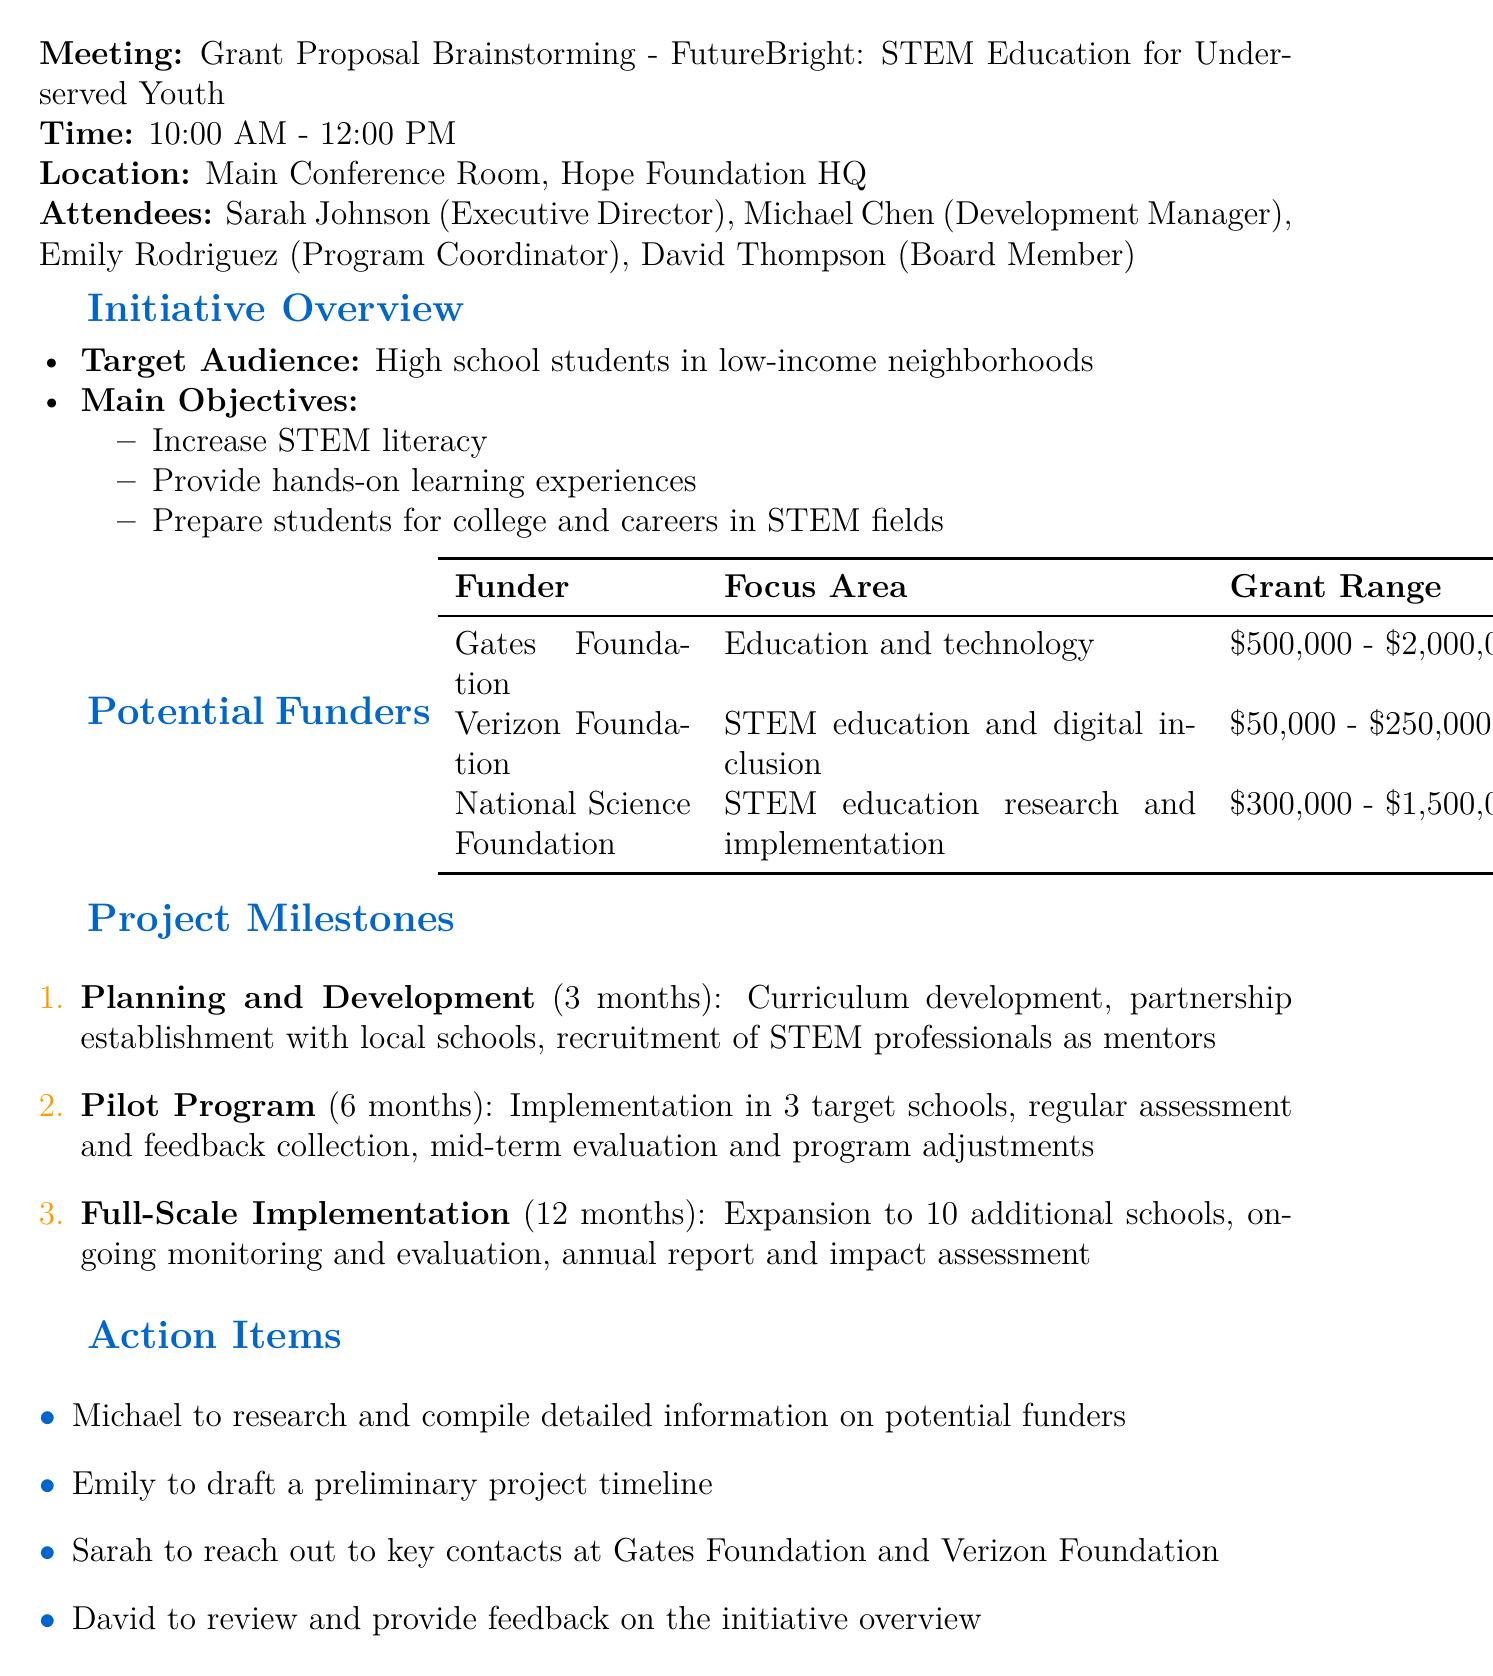What is the name of the initiative? The document states that the initiative is called "FutureBright: STEM Education for Underserved Youth."
Answer: FutureBright: STEM Education for Underserved Youth Who is the Program Coordinator? According to the attendees listed in the document, Emily Rodriguez holds the position of Program Coordinator.
Answer: Emily Rodriguez What is the duration of the Planning and Development phase? The document specifies that the duration for the Planning and Development phase is 3 months.
Answer: 3 months What is the grant range for the Verizon Foundation? The document indicates that the grant range for the Verizon Foundation is between $50,000 and $250,000.
Answer: $50,000 - $250,000 What is the focus area of the Gates Foundation? The document mentions that the focus area for the Gates Foundation is "Education and technology."
Answer: Education and technology What key activity is planned during the Pilot Program phase? One of the key activities mentioned in the Pilot Program phase is "Implementation in 3 target schools."
Answer: Implementation in 3 target schools What action item is assigned to Michael? The document states that Michael is to research and compile detailed information on potential funders.
Answer: Research and compile detailed information on potential funders How many additional schools will be included in the Full-Scale Implementation? The document specifies that the Full-Scale Implementation will expand to 10 additional schools.
Answer: 10 additional schools What date was the meeting held? The document lists May 15, 2023, as the date of the meeting.
Answer: May 15, 2023 